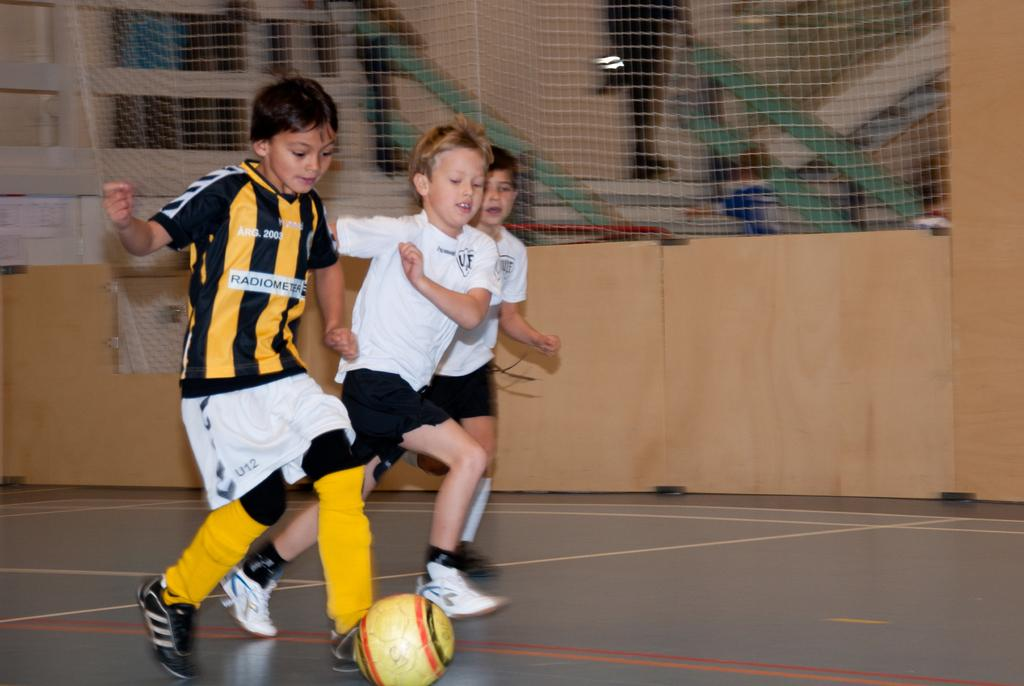How many boys are present in the image? There are three boys in the image. What are the boys doing in the image? The boys are running in the image. What is on the ground near the boys? There is a ball on the ground. What can be seen in the background of the image? There is a wall, a fencing net, wooden planks, and some objects in the background of the image. How many chairs are visible in the image? There are no chairs present in the image. What type of wash is being done in the image? There is no washing activity depicted in the image. 